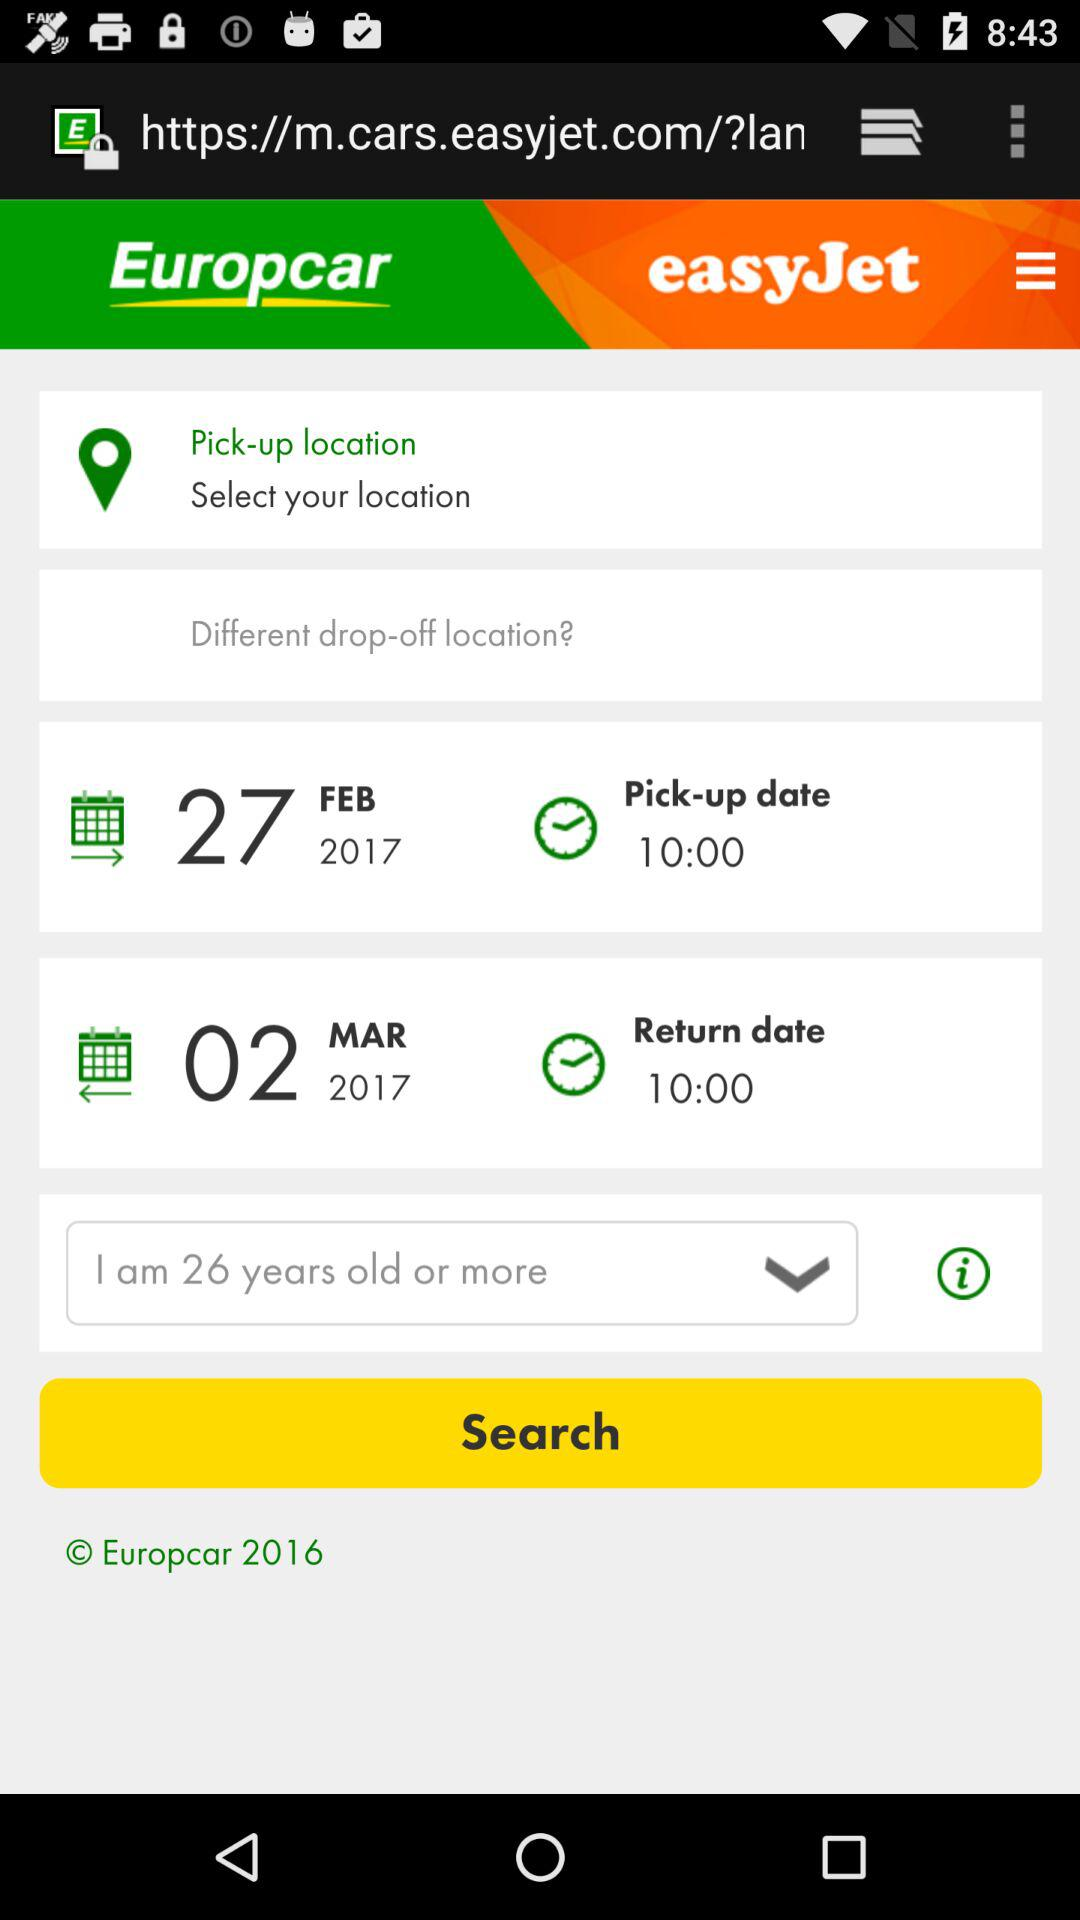What's the chosen age by the user? The chosen age is 26 years old or more. 